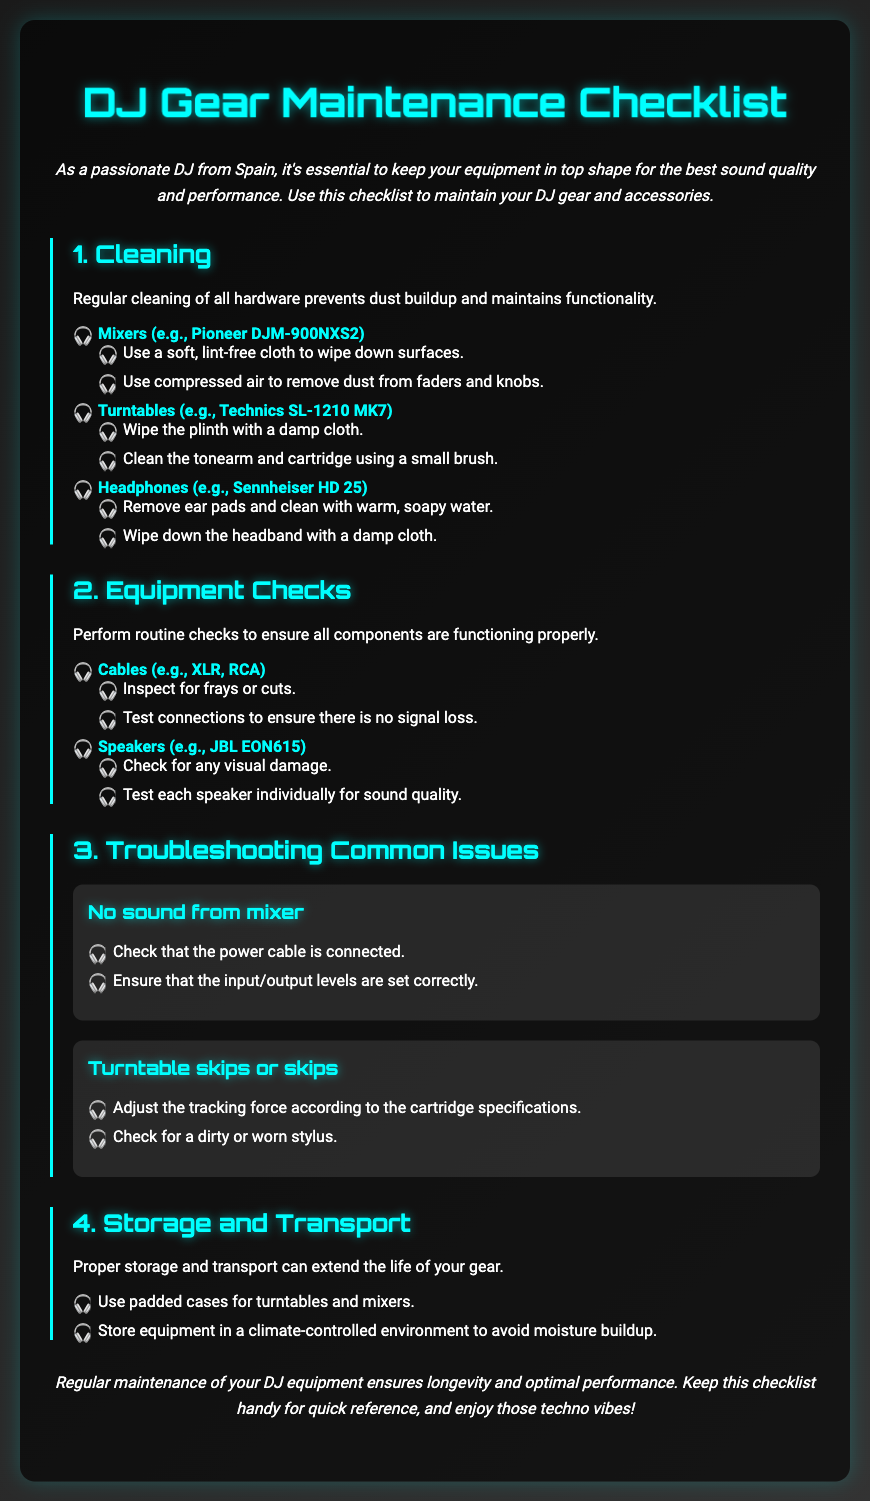What is the main purpose of the document? The document provides a checklist for maintaining DJ gear and accessories, emphasizing the importance of equipment upkeep for sound quality.
Answer: maintenance checklist How often should cleaning be performed on DJ equipment? The document implies regular cleaning is necessary to prevent dust buildup and maintain functionality.
Answer: regularly Which headphones are mentioned for cleaning? The document specifies Sennheiser HD 25 as the model of headphones to clean.
Answer: Sennheiser HD 25 What should be checked for frays or cuts? The document advises inspecting cables such as XLR and RCA for any frays or cuts.
Answer: cables What is one troubleshooting step for no sound from the mixer? The document states to check that the power cable is connected as a troubleshooting step.
Answer: power cable How should turntables and mixers be stored? The document recommends using padded cases for their storage.
Answer: padded cases What cleaning method is suggested for the tonearm and cartridge? The document suggests using a small brush to clean the tonearm and cartridge of turntables.
Answer: small brush What type of environment is recommended for storage? The document advises storing equipment in a climate-controlled environment to avoid moisture buildup.
Answer: climate-controlled What can adjusting to the cartridge specifications help resolve? The document indicates adjusting the tracking force can help resolve issues with turntable skips.
Answer: tracking force 